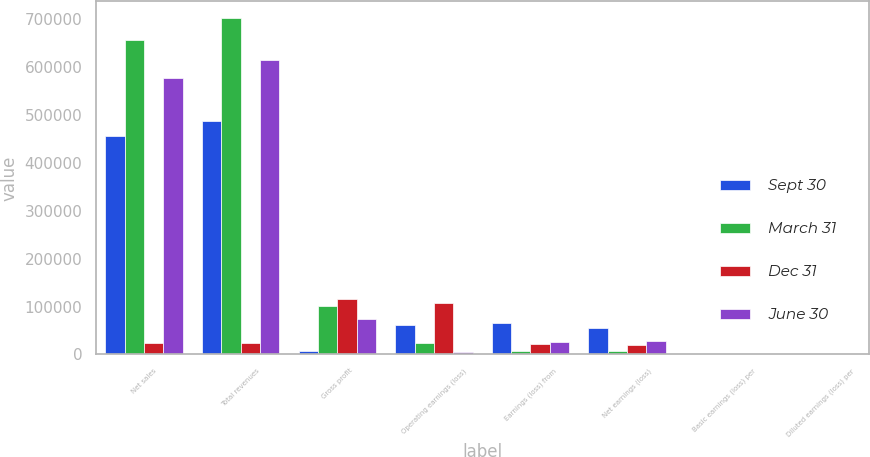Convert chart. <chart><loc_0><loc_0><loc_500><loc_500><stacked_bar_chart><ecel><fcel>Net sales<fcel>Total revenues<fcel>Gross profit<fcel>Operating earnings (loss)<fcel>Earnings (loss) from<fcel>Net earnings (loss)<fcel>Basic earnings (loss) per<fcel>Diluted earnings (loss) per<nl><fcel>Sept 30<fcel>456316<fcel>487200<fcel>7106<fcel>61184<fcel>64622<fcel>54733<fcel>0.5<fcel>0.5<nl><fcel>March 31<fcel>657457<fcel>701971<fcel>100840<fcel>23488<fcel>7102<fcel>8139<fcel>0.05<fcel>0.05<nl><fcel>Dec 31<fcel>24715.5<fcel>24715.5<fcel>115780<fcel>106668<fcel>22412<fcel>19959<fcel>0.17<fcel>0.17<nl><fcel>June 30<fcel>578189<fcel>614627<fcel>74355<fcel>5528<fcel>25943<fcel>27865<fcel>0.2<fcel>0.2<nl></chart> 